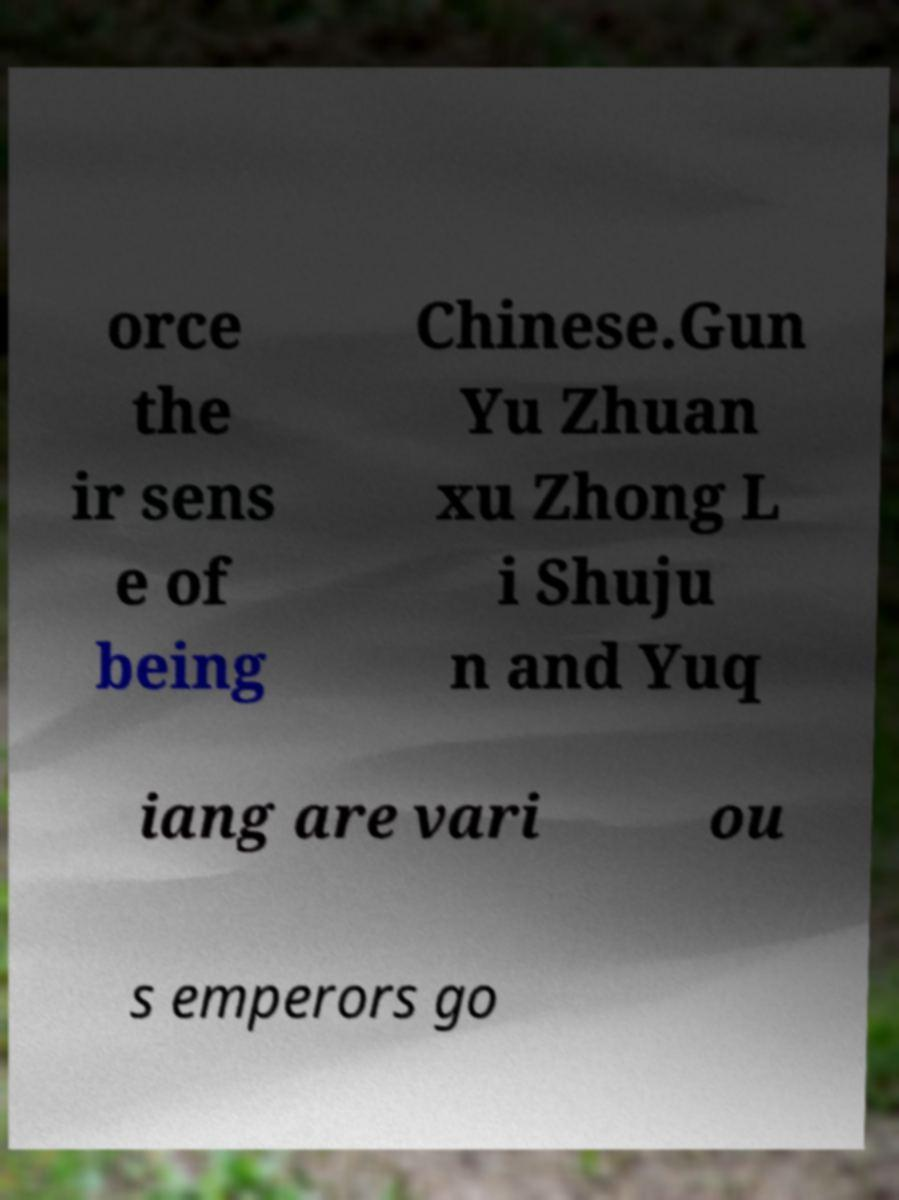I need the written content from this picture converted into text. Can you do that? orce the ir sens e of being Chinese.Gun Yu Zhuan xu Zhong L i Shuju n and Yuq iang are vari ou s emperors go 